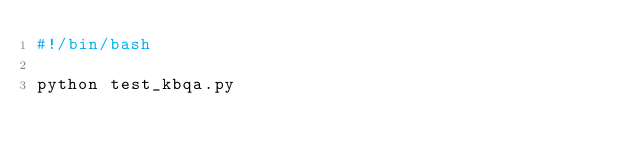<code> <loc_0><loc_0><loc_500><loc_500><_Bash_>#!/bin/bash

python test_kbqa.py
</code> 